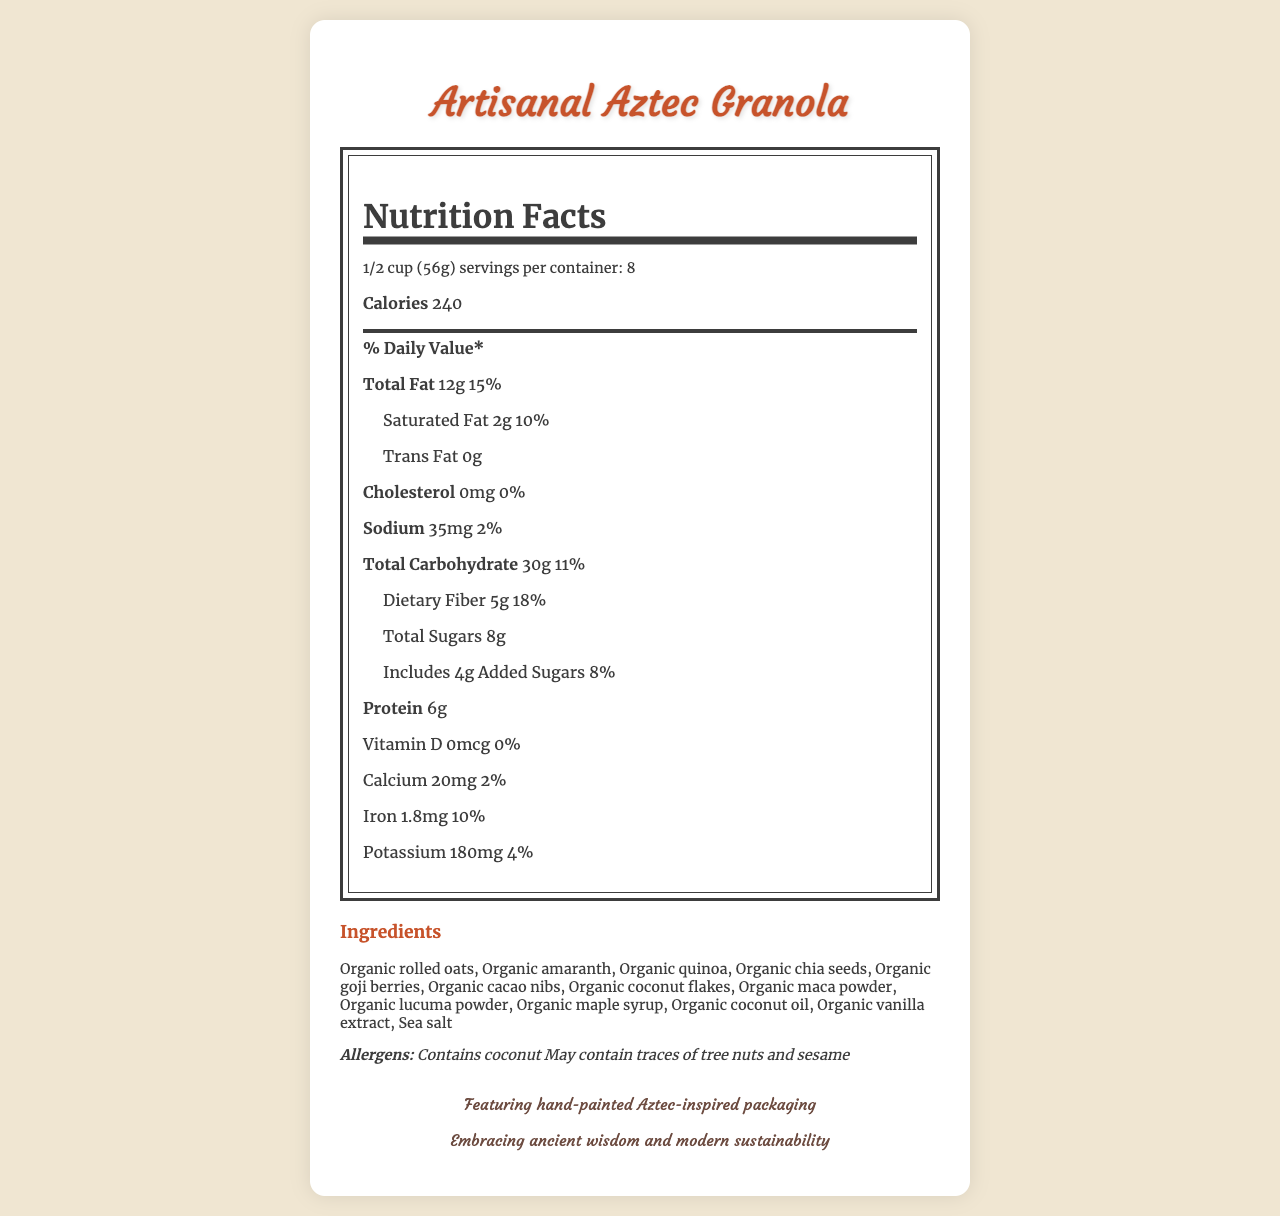how many servings are there per container? The document states "servings per container: 8".
Answer: 8 how many calories are there per serving? The document lists the calories as 240 per serving.
Answer: 240 what is the amount of total fat in one serving? The label shows "Total Fat: 12g".
Answer: 12g is there any cholesterol in this granola? The document states "Cholesterol: 0mg 0%".
Answer: No what are the first three ingredients listed? The ingredients are listed in order, starting with "Organic rolled oats, Organic amaranth, Organic quinoa".
Answer: Organic rolled oats, Organic amaranth, Organic quinoa what is the daily value percentage for dietary fiber? A. 10% B. 2% C. 18% D. 11% The document lists "Dietary Fiber: 5g 18%".
Answer: C. 18% which of the following is an allergen mentioned in the document? A. Gluten B. Tree nuts C. Soy D. Milk The document states "May contain traces of tree nuts and sesame".
Answer: B. Tree nuts what is included in the artistic elements of the packaging? A. Digital art B. Hand-painted illustrations C. Modern typography D. Silver foil accents The package features "Hand-painted illustrations".
Answer: B. Hand-painted illustrations does the packaging feature Aztec-inspired designs? The document mentions "Aztec-inspired geometric patterns in vibrant colors".
Answer: Yes summarize the main ideas of the document. The document starts with the product name and detailed nutritional facts. It then lists the ingredients and allergens, followed by a description of the hand-painted, sustainable packaging inspired by Aztec art, and concludes with the sustainability initiatives and artistic elements used.
Answer: The document provides detailed nutritional information about Artisanal Aztec Granola, highlighting ingredients such as exotic superfoods and traditional grains. It discusses the product's handmade Aztec-inspired packaging, sustainability features, and artistic elements. The granola is marketed as organic, fair trade, and supportive of small-scale farmers. who manufactures this granola? The document does not provide any information about the manufacturer.
Answer: Cannot be determined 